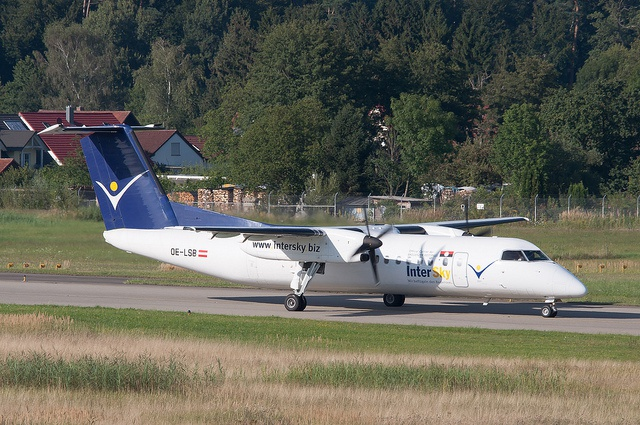Describe the objects in this image and their specific colors. I can see airplane in black, white, gray, and darkgray tones and car in black, gray, darkgray, and lightgray tones in this image. 